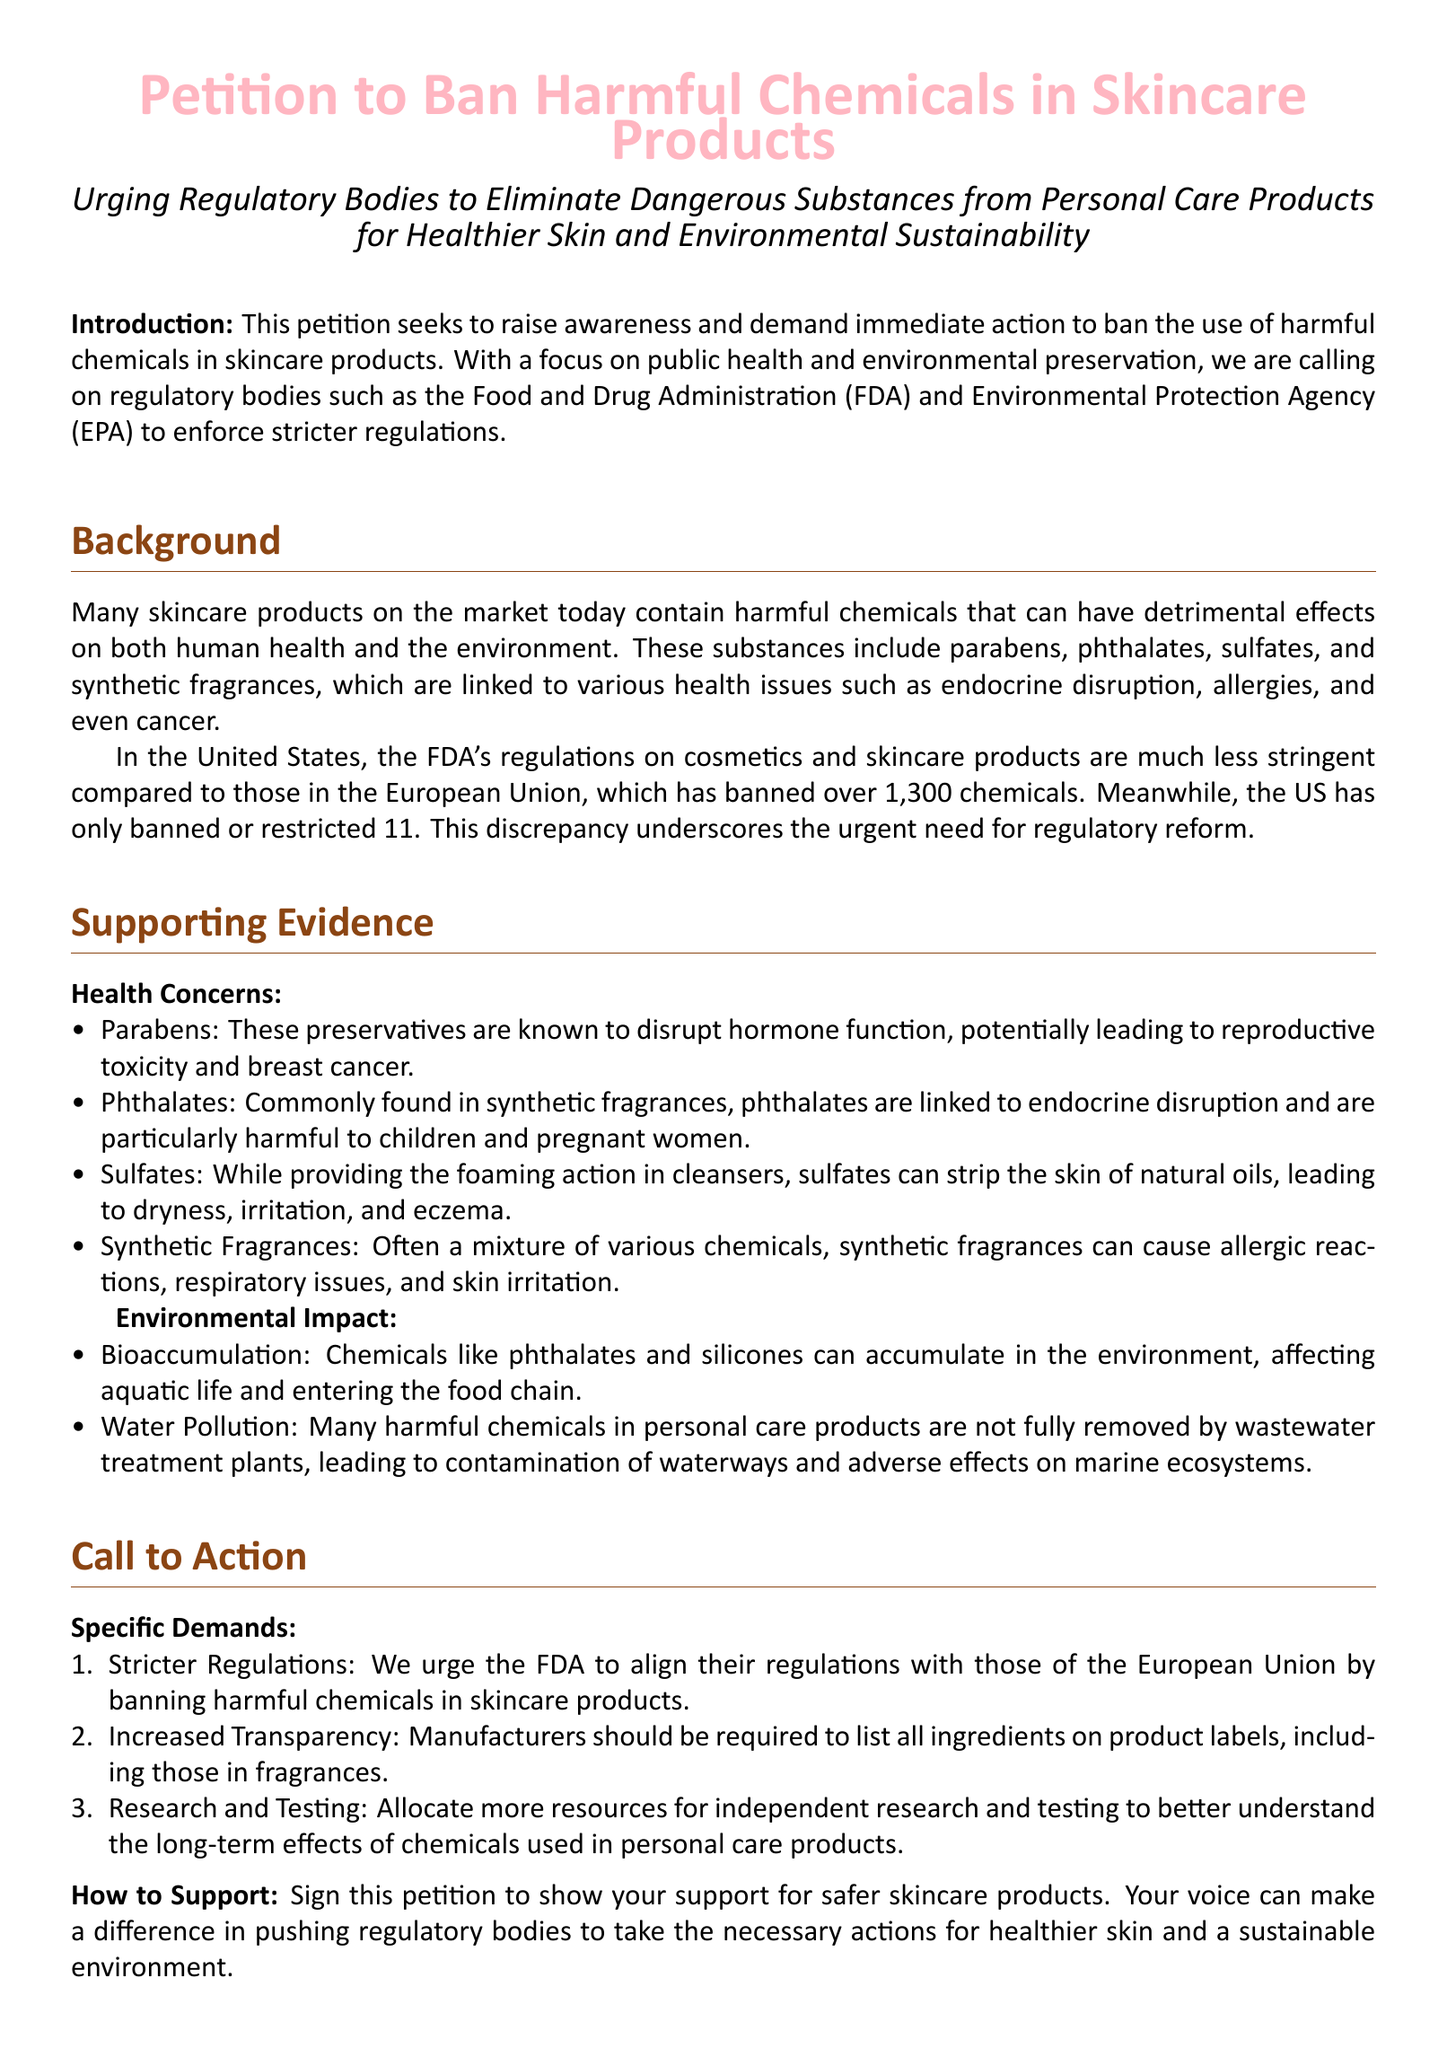What is the title of the petition? The title of the petition is stated at the beginning of the document.
Answer: Petition to Ban Harmful Chemicals in Skincare Products How many harmful chemicals has the EU banned? The document provides a comparison of bans between the EU and the US.
Answer: over 1,300 chemicals What is one health concern associated with parabens? The document lists health concerns, including specific effects linked to parabens.
Answer: reproductive toxicity What specific action does the petition urge the FDA to take? The petition outlines demands for regulatory changes from the FDA.
Answer: banning harmful chemicals What type of chemicals can accumulate in the environment? The document mentions specific harmful chemicals that impact the environment.
Answer: phthalates and silicones How should manufacturers improve transparency? The petition requests specific changes in how ingredients are listed.
Answer: list all ingredients on product labels What is the overall aim of this petition? The introduction outlines the purpose of the petition clearly.
Answer: promote healthier skin and environmental sustainability What constitutes a major difference in regulation mentioned in the petition? The petition draws attention to the differences in regulation between two regions.
Answer: FDA's regulations are less stringent than the EU's 